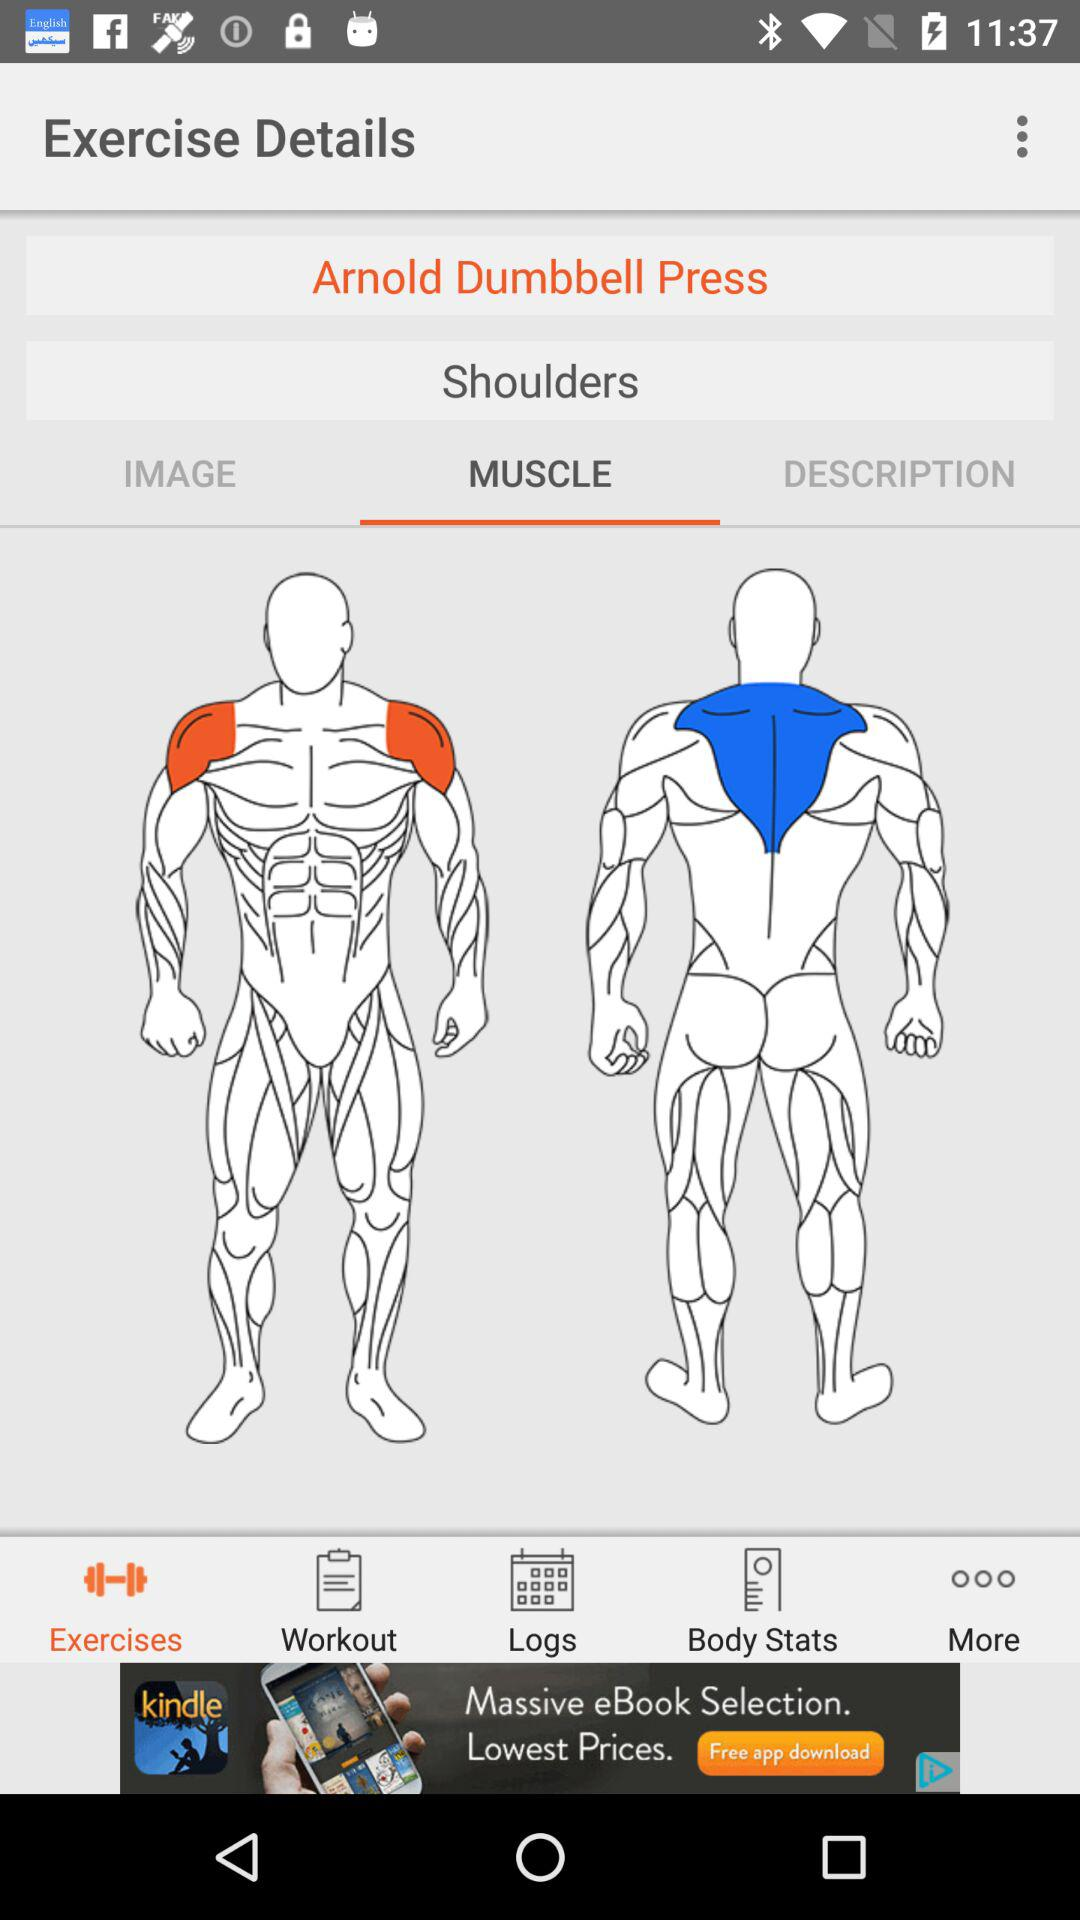How much is the user's weight?
When the provided information is insufficient, respond with <no answer>. <no answer> 